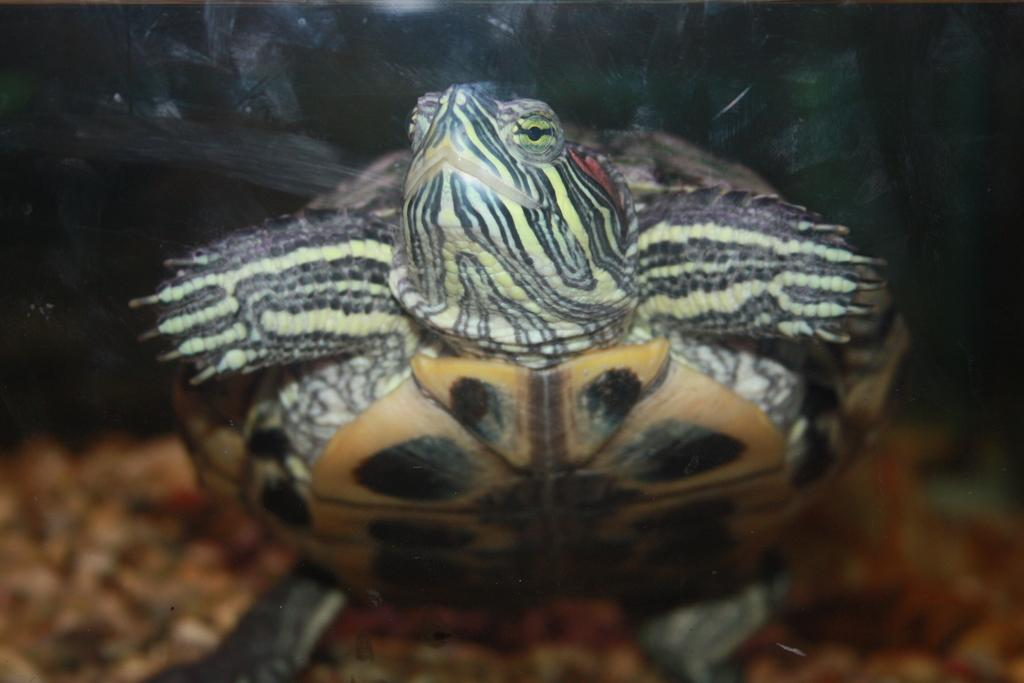What type of animal is in the image? There is a tortoise in the image. What type of action is the fireman performing in the image? There is no fireman present in the image; it only features a tortoise. 